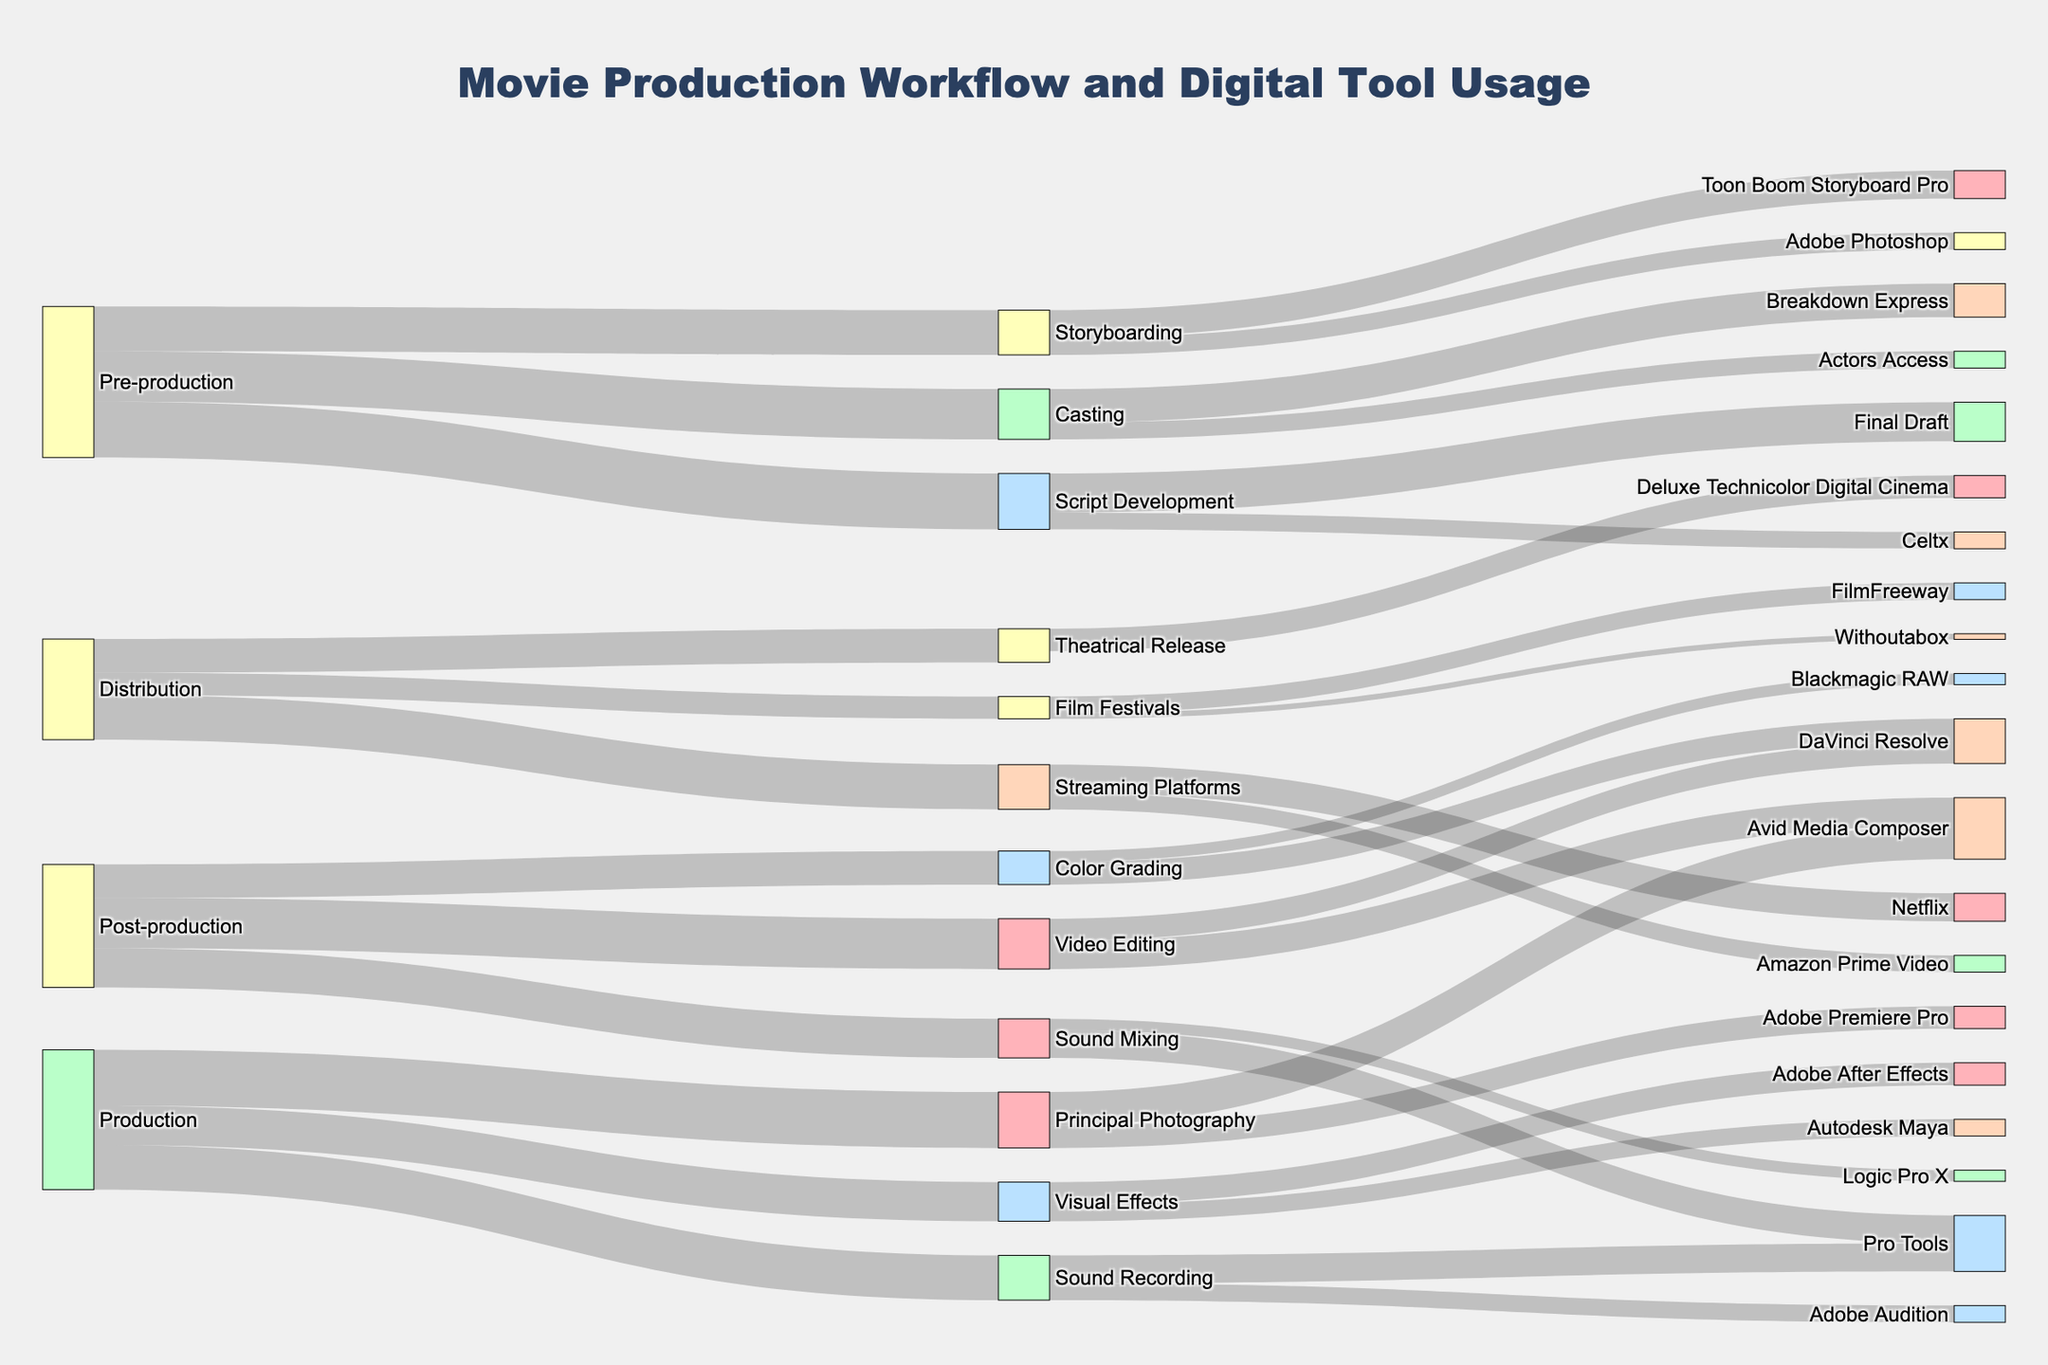How many stages are there in the movie production workflow? The figure shows nodes representing different stages, connected by links indicating transitions. Count the unique initial stages.
Answer: 4 Which digital tools are used in Pre-production? Look at the stages under Pre-production and identify the specific tools listed in the target nodes.
Answer: Celtx, Toon Boom Storyboard Pro, Adobe Photoshop, Breakdown Express, Actors Access What is the total value for the Script Development stage? Sum the values of the outgoing links from the Script Development node.
Answer: 100 Compare the values for Principal Photography in Avid Media Composer and Adobe Premiere Pro. Which one is higher? Check the values of the links from Principal Photography to Avid Media Composer and to Adobe Premiere Pro; Avid Media Composer is 60, Adobe Premiere Pro is 40.
Answer: Avid Media Composer What is the total distribution across Streaming Platforms? Add the values from Streaming Platforms to Netflix and Amazon Prime Video.
Answer: 80 What's the percentage of Sound Recording that uses Pro Tools? Divide the value for Pro Tools under Sound Recording by the total Sound Recording value and multiply by 100.
Answer: 62.5% How does the use of digital tools differ between Video Editing and Sound Mixing in Post-production? Compare the outgoing values from Video Editing to Avid Media Composer (50) and DaVinci Resolve (40) with those from Sound Mixing to Pro Tools (50) and Logic Pro X (20).
Answer: More varied in Video Editing Which stage uses the most nodes in its workflow? Look at each stage and count the number of nodes connected to it. Production has the most nodes connected.
Answer: Production What is the most common digital tool used across all stages? Identify the tool that appears most frequently across all nodes.
Answer: DaVinci Resolve 